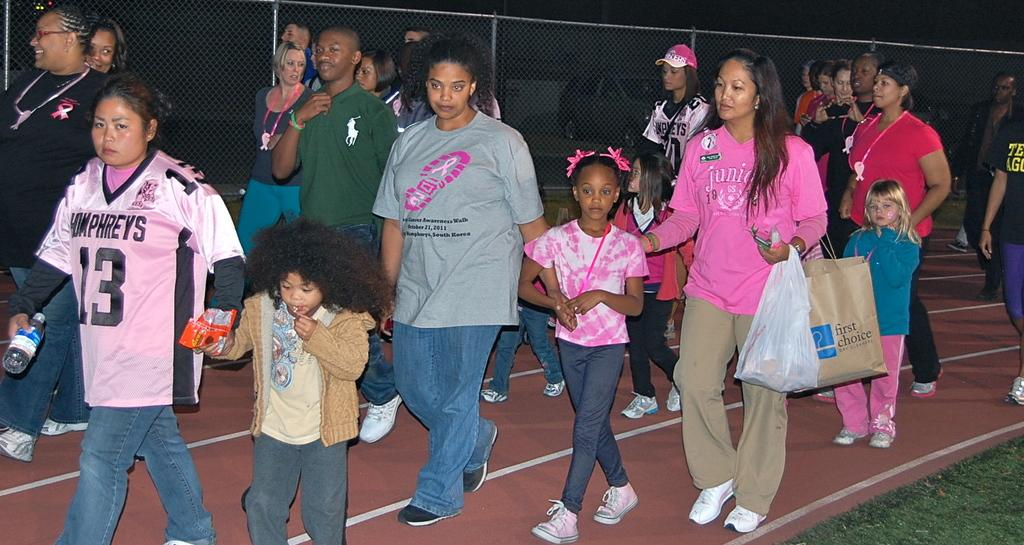<image>
Provide a brief description of the given image. The lady at the front is wearing a Humphreys 13 jersey. 